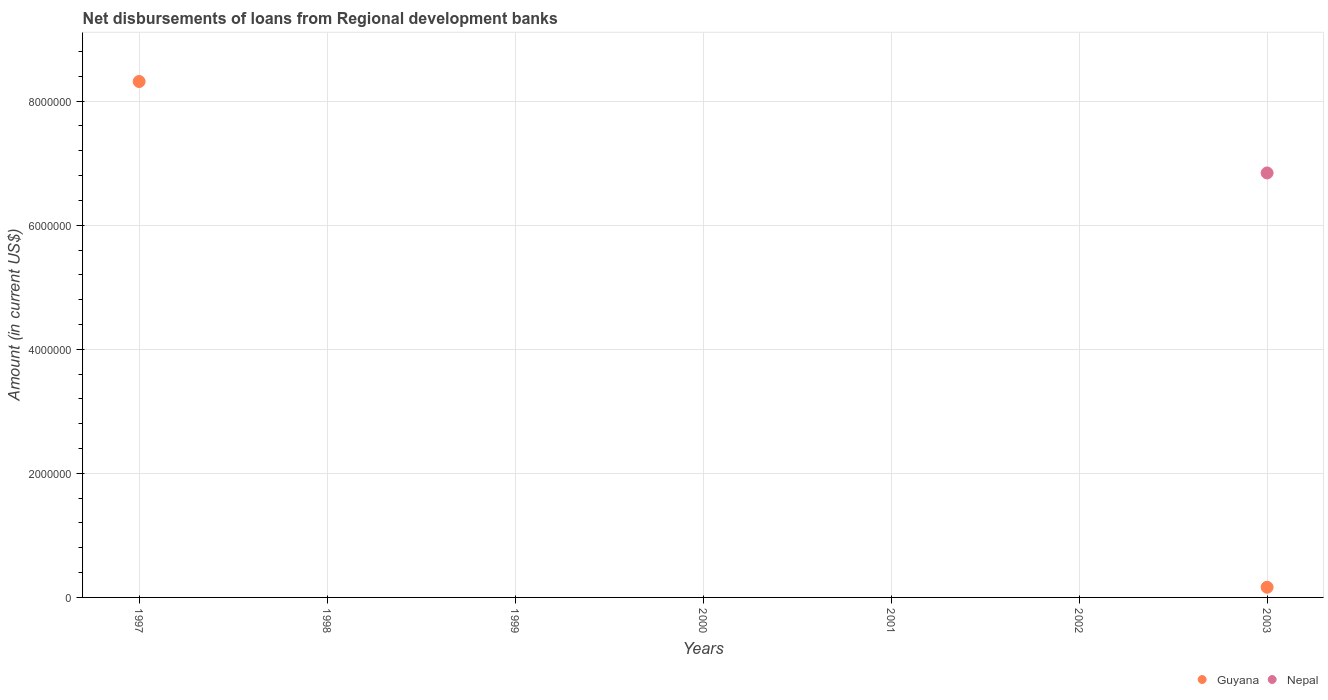How many different coloured dotlines are there?
Provide a short and direct response. 2. What is the amount of disbursements of loans from regional development banks in Guyana in 2001?
Offer a terse response. 0. Across all years, what is the maximum amount of disbursements of loans from regional development banks in Guyana?
Provide a succinct answer. 8.32e+06. Across all years, what is the minimum amount of disbursements of loans from regional development banks in Nepal?
Provide a short and direct response. 0. In which year was the amount of disbursements of loans from regional development banks in Nepal maximum?
Offer a terse response. 2003. What is the total amount of disbursements of loans from regional development banks in Nepal in the graph?
Your answer should be very brief. 6.84e+06. What is the difference between the amount of disbursements of loans from regional development banks in Guyana in 1997 and the amount of disbursements of loans from regional development banks in Nepal in 1999?
Keep it short and to the point. 8.32e+06. What is the average amount of disbursements of loans from regional development banks in Nepal per year?
Provide a succinct answer. 9.77e+05. In the year 2003, what is the difference between the amount of disbursements of loans from regional development banks in Guyana and amount of disbursements of loans from regional development banks in Nepal?
Provide a short and direct response. -6.68e+06. What is the difference between the highest and the lowest amount of disbursements of loans from regional development banks in Nepal?
Give a very brief answer. 6.84e+06. In how many years, is the amount of disbursements of loans from regional development banks in Nepal greater than the average amount of disbursements of loans from regional development banks in Nepal taken over all years?
Give a very brief answer. 1. Does the amount of disbursements of loans from regional development banks in Guyana monotonically increase over the years?
Offer a terse response. No. Is the amount of disbursements of loans from regional development banks in Guyana strictly less than the amount of disbursements of loans from regional development banks in Nepal over the years?
Provide a succinct answer. No. What is the difference between two consecutive major ticks on the Y-axis?
Provide a short and direct response. 2.00e+06. Are the values on the major ticks of Y-axis written in scientific E-notation?
Offer a very short reply. No. Does the graph contain grids?
Your response must be concise. Yes. What is the title of the graph?
Provide a succinct answer. Net disbursements of loans from Regional development banks. What is the label or title of the Y-axis?
Your answer should be compact. Amount (in current US$). What is the Amount (in current US$) of Guyana in 1997?
Provide a short and direct response. 8.32e+06. What is the Amount (in current US$) of Nepal in 1997?
Provide a short and direct response. 0. What is the Amount (in current US$) of Nepal in 2000?
Offer a terse response. 0. What is the Amount (in current US$) of Guyana in 2001?
Give a very brief answer. 0. What is the Amount (in current US$) in Guyana in 2003?
Offer a very short reply. 1.64e+05. What is the Amount (in current US$) in Nepal in 2003?
Offer a terse response. 6.84e+06. Across all years, what is the maximum Amount (in current US$) of Guyana?
Offer a terse response. 8.32e+06. Across all years, what is the maximum Amount (in current US$) in Nepal?
Your answer should be compact. 6.84e+06. Across all years, what is the minimum Amount (in current US$) in Guyana?
Make the answer very short. 0. Across all years, what is the minimum Amount (in current US$) of Nepal?
Your response must be concise. 0. What is the total Amount (in current US$) of Guyana in the graph?
Your response must be concise. 8.48e+06. What is the total Amount (in current US$) of Nepal in the graph?
Make the answer very short. 6.84e+06. What is the difference between the Amount (in current US$) in Guyana in 1997 and that in 2003?
Provide a short and direct response. 8.15e+06. What is the difference between the Amount (in current US$) of Guyana in 1997 and the Amount (in current US$) of Nepal in 2003?
Make the answer very short. 1.47e+06. What is the average Amount (in current US$) of Guyana per year?
Offer a very short reply. 1.21e+06. What is the average Amount (in current US$) of Nepal per year?
Ensure brevity in your answer.  9.77e+05. In the year 2003, what is the difference between the Amount (in current US$) in Guyana and Amount (in current US$) in Nepal?
Provide a short and direct response. -6.68e+06. What is the ratio of the Amount (in current US$) of Guyana in 1997 to that in 2003?
Offer a terse response. 50.71. What is the difference between the highest and the lowest Amount (in current US$) in Guyana?
Provide a short and direct response. 8.32e+06. What is the difference between the highest and the lowest Amount (in current US$) in Nepal?
Offer a very short reply. 6.84e+06. 